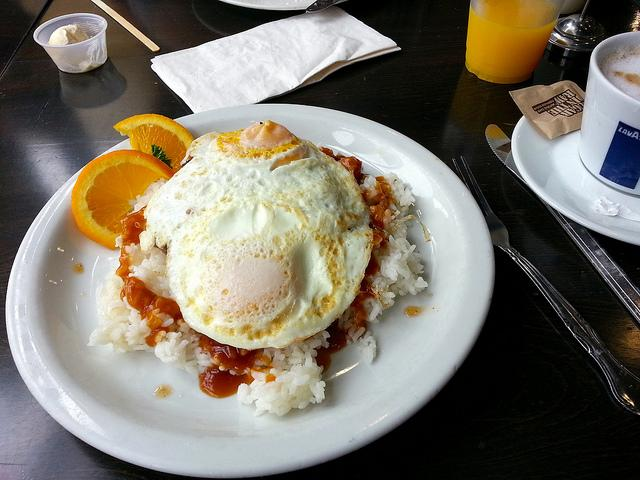What is in the tall glass on the right hand side? orange juice 